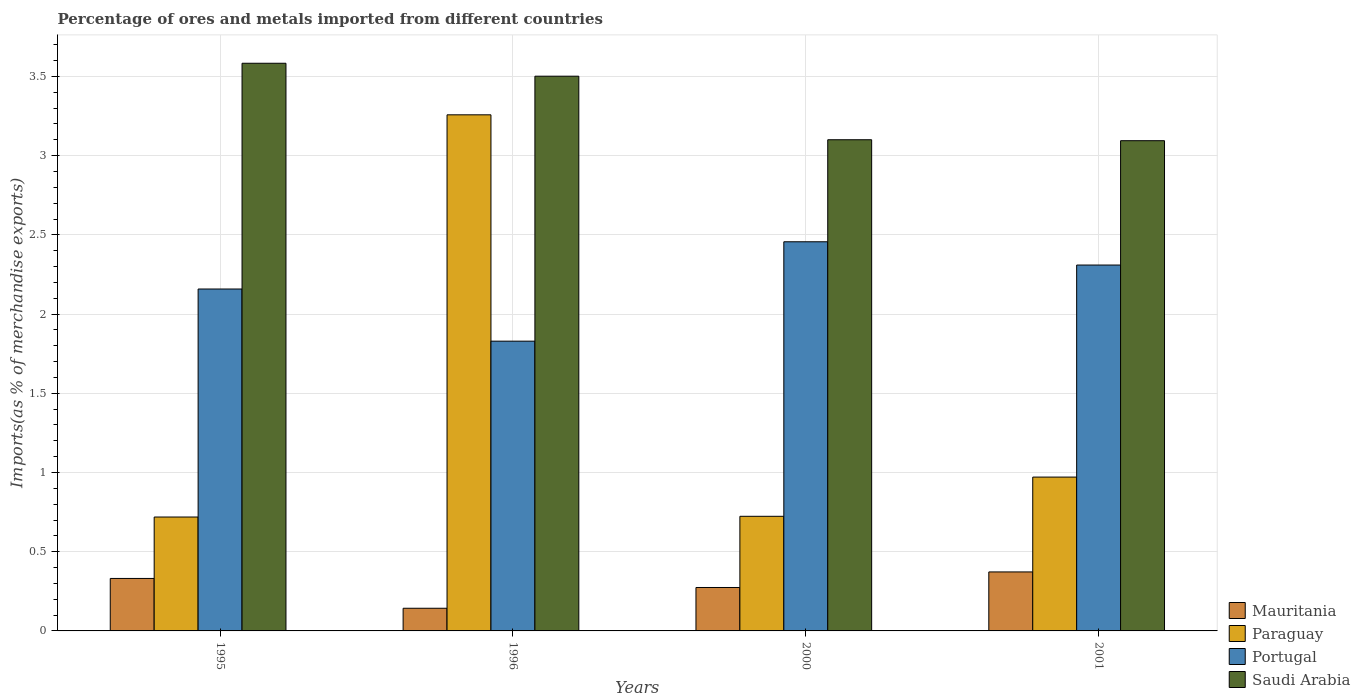How many bars are there on the 1st tick from the left?
Provide a short and direct response. 4. What is the label of the 3rd group of bars from the left?
Offer a terse response. 2000. In how many cases, is the number of bars for a given year not equal to the number of legend labels?
Give a very brief answer. 0. What is the percentage of imports to different countries in Saudi Arabia in 2000?
Offer a very short reply. 3.1. Across all years, what is the maximum percentage of imports to different countries in Mauritania?
Give a very brief answer. 0.37. Across all years, what is the minimum percentage of imports to different countries in Portugal?
Make the answer very short. 1.83. In which year was the percentage of imports to different countries in Saudi Arabia maximum?
Your answer should be very brief. 1995. What is the total percentage of imports to different countries in Saudi Arabia in the graph?
Provide a succinct answer. 13.28. What is the difference between the percentage of imports to different countries in Saudi Arabia in 1996 and that in 2001?
Your answer should be compact. 0.41. What is the difference between the percentage of imports to different countries in Portugal in 1996 and the percentage of imports to different countries in Saudi Arabia in 1995?
Ensure brevity in your answer.  -1.75. What is the average percentage of imports to different countries in Portugal per year?
Offer a very short reply. 2.19. In the year 2001, what is the difference between the percentage of imports to different countries in Mauritania and percentage of imports to different countries in Paraguay?
Make the answer very short. -0.6. What is the ratio of the percentage of imports to different countries in Portugal in 1995 to that in 1996?
Provide a short and direct response. 1.18. Is the difference between the percentage of imports to different countries in Mauritania in 1996 and 2001 greater than the difference between the percentage of imports to different countries in Paraguay in 1996 and 2001?
Offer a terse response. No. What is the difference between the highest and the second highest percentage of imports to different countries in Saudi Arabia?
Offer a very short reply. 0.08. What is the difference between the highest and the lowest percentage of imports to different countries in Paraguay?
Provide a succinct answer. 2.54. In how many years, is the percentage of imports to different countries in Saudi Arabia greater than the average percentage of imports to different countries in Saudi Arabia taken over all years?
Provide a succinct answer. 2. What does the 2nd bar from the left in 2000 represents?
Your response must be concise. Paraguay. What does the 4th bar from the right in 1996 represents?
Ensure brevity in your answer.  Mauritania. Is it the case that in every year, the sum of the percentage of imports to different countries in Portugal and percentage of imports to different countries in Paraguay is greater than the percentage of imports to different countries in Saudi Arabia?
Your response must be concise. No. Are all the bars in the graph horizontal?
Give a very brief answer. No. How many years are there in the graph?
Keep it short and to the point. 4. Does the graph contain any zero values?
Provide a short and direct response. No. Does the graph contain grids?
Ensure brevity in your answer.  Yes. How are the legend labels stacked?
Your answer should be compact. Vertical. What is the title of the graph?
Provide a succinct answer. Percentage of ores and metals imported from different countries. Does "Chad" appear as one of the legend labels in the graph?
Offer a terse response. No. What is the label or title of the Y-axis?
Your answer should be compact. Imports(as % of merchandise exports). What is the Imports(as % of merchandise exports) in Mauritania in 1995?
Provide a short and direct response. 0.33. What is the Imports(as % of merchandise exports) of Paraguay in 1995?
Your response must be concise. 0.72. What is the Imports(as % of merchandise exports) of Portugal in 1995?
Provide a short and direct response. 2.16. What is the Imports(as % of merchandise exports) of Saudi Arabia in 1995?
Offer a very short reply. 3.58. What is the Imports(as % of merchandise exports) in Mauritania in 1996?
Provide a succinct answer. 0.14. What is the Imports(as % of merchandise exports) in Paraguay in 1996?
Make the answer very short. 3.26. What is the Imports(as % of merchandise exports) of Portugal in 1996?
Make the answer very short. 1.83. What is the Imports(as % of merchandise exports) in Saudi Arabia in 1996?
Provide a short and direct response. 3.5. What is the Imports(as % of merchandise exports) of Mauritania in 2000?
Your answer should be very brief. 0.27. What is the Imports(as % of merchandise exports) of Paraguay in 2000?
Keep it short and to the point. 0.72. What is the Imports(as % of merchandise exports) in Portugal in 2000?
Ensure brevity in your answer.  2.46. What is the Imports(as % of merchandise exports) of Saudi Arabia in 2000?
Ensure brevity in your answer.  3.1. What is the Imports(as % of merchandise exports) of Mauritania in 2001?
Offer a very short reply. 0.37. What is the Imports(as % of merchandise exports) in Paraguay in 2001?
Offer a very short reply. 0.97. What is the Imports(as % of merchandise exports) in Portugal in 2001?
Keep it short and to the point. 2.31. What is the Imports(as % of merchandise exports) of Saudi Arabia in 2001?
Your answer should be compact. 3.09. Across all years, what is the maximum Imports(as % of merchandise exports) of Mauritania?
Give a very brief answer. 0.37. Across all years, what is the maximum Imports(as % of merchandise exports) in Paraguay?
Your answer should be very brief. 3.26. Across all years, what is the maximum Imports(as % of merchandise exports) in Portugal?
Provide a succinct answer. 2.46. Across all years, what is the maximum Imports(as % of merchandise exports) of Saudi Arabia?
Ensure brevity in your answer.  3.58. Across all years, what is the minimum Imports(as % of merchandise exports) in Mauritania?
Your answer should be compact. 0.14. Across all years, what is the minimum Imports(as % of merchandise exports) of Paraguay?
Provide a succinct answer. 0.72. Across all years, what is the minimum Imports(as % of merchandise exports) in Portugal?
Give a very brief answer. 1.83. Across all years, what is the minimum Imports(as % of merchandise exports) in Saudi Arabia?
Make the answer very short. 3.09. What is the total Imports(as % of merchandise exports) of Mauritania in the graph?
Your response must be concise. 1.12. What is the total Imports(as % of merchandise exports) in Paraguay in the graph?
Ensure brevity in your answer.  5.67. What is the total Imports(as % of merchandise exports) of Portugal in the graph?
Your answer should be very brief. 8.75. What is the total Imports(as % of merchandise exports) in Saudi Arabia in the graph?
Provide a short and direct response. 13.28. What is the difference between the Imports(as % of merchandise exports) in Mauritania in 1995 and that in 1996?
Your answer should be very brief. 0.19. What is the difference between the Imports(as % of merchandise exports) in Paraguay in 1995 and that in 1996?
Your answer should be very brief. -2.54. What is the difference between the Imports(as % of merchandise exports) of Portugal in 1995 and that in 1996?
Your answer should be compact. 0.33. What is the difference between the Imports(as % of merchandise exports) of Saudi Arabia in 1995 and that in 1996?
Ensure brevity in your answer.  0.08. What is the difference between the Imports(as % of merchandise exports) in Mauritania in 1995 and that in 2000?
Ensure brevity in your answer.  0.06. What is the difference between the Imports(as % of merchandise exports) of Paraguay in 1995 and that in 2000?
Give a very brief answer. -0. What is the difference between the Imports(as % of merchandise exports) in Portugal in 1995 and that in 2000?
Your answer should be compact. -0.3. What is the difference between the Imports(as % of merchandise exports) of Saudi Arabia in 1995 and that in 2000?
Give a very brief answer. 0.48. What is the difference between the Imports(as % of merchandise exports) of Mauritania in 1995 and that in 2001?
Ensure brevity in your answer.  -0.04. What is the difference between the Imports(as % of merchandise exports) of Paraguay in 1995 and that in 2001?
Keep it short and to the point. -0.25. What is the difference between the Imports(as % of merchandise exports) of Portugal in 1995 and that in 2001?
Ensure brevity in your answer.  -0.15. What is the difference between the Imports(as % of merchandise exports) of Saudi Arabia in 1995 and that in 2001?
Ensure brevity in your answer.  0.49. What is the difference between the Imports(as % of merchandise exports) in Mauritania in 1996 and that in 2000?
Provide a succinct answer. -0.13. What is the difference between the Imports(as % of merchandise exports) in Paraguay in 1996 and that in 2000?
Give a very brief answer. 2.53. What is the difference between the Imports(as % of merchandise exports) in Portugal in 1996 and that in 2000?
Your answer should be very brief. -0.63. What is the difference between the Imports(as % of merchandise exports) of Saudi Arabia in 1996 and that in 2000?
Give a very brief answer. 0.4. What is the difference between the Imports(as % of merchandise exports) in Mauritania in 1996 and that in 2001?
Provide a short and direct response. -0.23. What is the difference between the Imports(as % of merchandise exports) in Paraguay in 1996 and that in 2001?
Your answer should be very brief. 2.29. What is the difference between the Imports(as % of merchandise exports) in Portugal in 1996 and that in 2001?
Offer a terse response. -0.48. What is the difference between the Imports(as % of merchandise exports) in Saudi Arabia in 1996 and that in 2001?
Ensure brevity in your answer.  0.41. What is the difference between the Imports(as % of merchandise exports) of Mauritania in 2000 and that in 2001?
Ensure brevity in your answer.  -0.1. What is the difference between the Imports(as % of merchandise exports) of Paraguay in 2000 and that in 2001?
Offer a very short reply. -0.25. What is the difference between the Imports(as % of merchandise exports) of Portugal in 2000 and that in 2001?
Give a very brief answer. 0.15. What is the difference between the Imports(as % of merchandise exports) of Saudi Arabia in 2000 and that in 2001?
Give a very brief answer. 0.01. What is the difference between the Imports(as % of merchandise exports) of Mauritania in 1995 and the Imports(as % of merchandise exports) of Paraguay in 1996?
Offer a terse response. -2.93. What is the difference between the Imports(as % of merchandise exports) in Mauritania in 1995 and the Imports(as % of merchandise exports) in Portugal in 1996?
Provide a short and direct response. -1.5. What is the difference between the Imports(as % of merchandise exports) of Mauritania in 1995 and the Imports(as % of merchandise exports) of Saudi Arabia in 1996?
Keep it short and to the point. -3.17. What is the difference between the Imports(as % of merchandise exports) of Paraguay in 1995 and the Imports(as % of merchandise exports) of Portugal in 1996?
Provide a short and direct response. -1.11. What is the difference between the Imports(as % of merchandise exports) of Paraguay in 1995 and the Imports(as % of merchandise exports) of Saudi Arabia in 1996?
Keep it short and to the point. -2.78. What is the difference between the Imports(as % of merchandise exports) in Portugal in 1995 and the Imports(as % of merchandise exports) in Saudi Arabia in 1996?
Offer a terse response. -1.34. What is the difference between the Imports(as % of merchandise exports) in Mauritania in 1995 and the Imports(as % of merchandise exports) in Paraguay in 2000?
Offer a terse response. -0.39. What is the difference between the Imports(as % of merchandise exports) in Mauritania in 1995 and the Imports(as % of merchandise exports) in Portugal in 2000?
Provide a short and direct response. -2.13. What is the difference between the Imports(as % of merchandise exports) in Mauritania in 1995 and the Imports(as % of merchandise exports) in Saudi Arabia in 2000?
Provide a short and direct response. -2.77. What is the difference between the Imports(as % of merchandise exports) in Paraguay in 1995 and the Imports(as % of merchandise exports) in Portugal in 2000?
Make the answer very short. -1.74. What is the difference between the Imports(as % of merchandise exports) in Paraguay in 1995 and the Imports(as % of merchandise exports) in Saudi Arabia in 2000?
Give a very brief answer. -2.38. What is the difference between the Imports(as % of merchandise exports) in Portugal in 1995 and the Imports(as % of merchandise exports) in Saudi Arabia in 2000?
Make the answer very short. -0.94. What is the difference between the Imports(as % of merchandise exports) of Mauritania in 1995 and the Imports(as % of merchandise exports) of Paraguay in 2001?
Ensure brevity in your answer.  -0.64. What is the difference between the Imports(as % of merchandise exports) of Mauritania in 1995 and the Imports(as % of merchandise exports) of Portugal in 2001?
Provide a succinct answer. -1.98. What is the difference between the Imports(as % of merchandise exports) of Mauritania in 1995 and the Imports(as % of merchandise exports) of Saudi Arabia in 2001?
Ensure brevity in your answer.  -2.76. What is the difference between the Imports(as % of merchandise exports) of Paraguay in 1995 and the Imports(as % of merchandise exports) of Portugal in 2001?
Keep it short and to the point. -1.59. What is the difference between the Imports(as % of merchandise exports) in Paraguay in 1995 and the Imports(as % of merchandise exports) in Saudi Arabia in 2001?
Offer a very short reply. -2.38. What is the difference between the Imports(as % of merchandise exports) of Portugal in 1995 and the Imports(as % of merchandise exports) of Saudi Arabia in 2001?
Provide a succinct answer. -0.94. What is the difference between the Imports(as % of merchandise exports) of Mauritania in 1996 and the Imports(as % of merchandise exports) of Paraguay in 2000?
Provide a succinct answer. -0.58. What is the difference between the Imports(as % of merchandise exports) of Mauritania in 1996 and the Imports(as % of merchandise exports) of Portugal in 2000?
Give a very brief answer. -2.31. What is the difference between the Imports(as % of merchandise exports) in Mauritania in 1996 and the Imports(as % of merchandise exports) in Saudi Arabia in 2000?
Offer a very short reply. -2.96. What is the difference between the Imports(as % of merchandise exports) of Paraguay in 1996 and the Imports(as % of merchandise exports) of Portugal in 2000?
Give a very brief answer. 0.8. What is the difference between the Imports(as % of merchandise exports) in Paraguay in 1996 and the Imports(as % of merchandise exports) in Saudi Arabia in 2000?
Keep it short and to the point. 0.16. What is the difference between the Imports(as % of merchandise exports) of Portugal in 1996 and the Imports(as % of merchandise exports) of Saudi Arabia in 2000?
Make the answer very short. -1.27. What is the difference between the Imports(as % of merchandise exports) of Mauritania in 1996 and the Imports(as % of merchandise exports) of Paraguay in 2001?
Give a very brief answer. -0.83. What is the difference between the Imports(as % of merchandise exports) in Mauritania in 1996 and the Imports(as % of merchandise exports) in Portugal in 2001?
Offer a very short reply. -2.17. What is the difference between the Imports(as % of merchandise exports) of Mauritania in 1996 and the Imports(as % of merchandise exports) of Saudi Arabia in 2001?
Provide a succinct answer. -2.95. What is the difference between the Imports(as % of merchandise exports) of Paraguay in 1996 and the Imports(as % of merchandise exports) of Portugal in 2001?
Your answer should be very brief. 0.95. What is the difference between the Imports(as % of merchandise exports) in Paraguay in 1996 and the Imports(as % of merchandise exports) in Saudi Arabia in 2001?
Ensure brevity in your answer.  0.16. What is the difference between the Imports(as % of merchandise exports) of Portugal in 1996 and the Imports(as % of merchandise exports) of Saudi Arabia in 2001?
Make the answer very short. -1.27. What is the difference between the Imports(as % of merchandise exports) of Mauritania in 2000 and the Imports(as % of merchandise exports) of Paraguay in 2001?
Offer a very short reply. -0.7. What is the difference between the Imports(as % of merchandise exports) of Mauritania in 2000 and the Imports(as % of merchandise exports) of Portugal in 2001?
Give a very brief answer. -2.04. What is the difference between the Imports(as % of merchandise exports) of Mauritania in 2000 and the Imports(as % of merchandise exports) of Saudi Arabia in 2001?
Keep it short and to the point. -2.82. What is the difference between the Imports(as % of merchandise exports) in Paraguay in 2000 and the Imports(as % of merchandise exports) in Portugal in 2001?
Provide a succinct answer. -1.59. What is the difference between the Imports(as % of merchandise exports) of Paraguay in 2000 and the Imports(as % of merchandise exports) of Saudi Arabia in 2001?
Keep it short and to the point. -2.37. What is the difference between the Imports(as % of merchandise exports) in Portugal in 2000 and the Imports(as % of merchandise exports) in Saudi Arabia in 2001?
Your answer should be compact. -0.64. What is the average Imports(as % of merchandise exports) of Mauritania per year?
Offer a very short reply. 0.28. What is the average Imports(as % of merchandise exports) of Paraguay per year?
Offer a terse response. 1.42. What is the average Imports(as % of merchandise exports) in Portugal per year?
Provide a short and direct response. 2.19. What is the average Imports(as % of merchandise exports) of Saudi Arabia per year?
Offer a terse response. 3.32. In the year 1995, what is the difference between the Imports(as % of merchandise exports) of Mauritania and Imports(as % of merchandise exports) of Paraguay?
Make the answer very short. -0.39. In the year 1995, what is the difference between the Imports(as % of merchandise exports) in Mauritania and Imports(as % of merchandise exports) in Portugal?
Your answer should be compact. -1.83. In the year 1995, what is the difference between the Imports(as % of merchandise exports) of Mauritania and Imports(as % of merchandise exports) of Saudi Arabia?
Provide a succinct answer. -3.25. In the year 1995, what is the difference between the Imports(as % of merchandise exports) of Paraguay and Imports(as % of merchandise exports) of Portugal?
Your answer should be very brief. -1.44. In the year 1995, what is the difference between the Imports(as % of merchandise exports) of Paraguay and Imports(as % of merchandise exports) of Saudi Arabia?
Your answer should be very brief. -2.86. In the year 1995, what is the difference between the Imports(as % of merchandise exports) in Portugal and Imports(as % of merchandise exports) in Saudi Arabia?
Keep it short and to the point. -1.43. In the year 1996, what is the difference between the Imports(as % of merchandise exports) in Mauritania and Imports(as % of merchandise exports) in Paraguay?
Provide a succinct answer. -3.11. In the year 1996, what is the difference between the Imports(as % of merchandise exports) in Mauritania and Imports(as % of merchandise exports) in Portugal?
Provide a succinct answer. -1.69. In the year 1996, what is the difference between the Imports(as % of merchandise exports) of Mauritania and Imports(as % of merchandise exports) of Saudi Arabia?
Your response must be concise. -3.36. In the year 1996, what is the difference between the Imports(as % of merchandise exports) of Paraguay and Imports(as % of merchandise exports) of Portugal?
Offer a terse response. 1.43. In the year 1996, what is the difference between the Imports(as % of merchandise exports) of Paraguay and Imports(as % of merchandise exports) of Saudi Arabia?
Your response must be concise. -0.24. In the year 1996, what is the difference between the Imports(as % of merchandise exports) of Portugal and Imports(as % of merchandise exports) of Saudi Arabia?
Ensure brevity in your answer.  -1.67. In the year 2000, what is the difference between the Imports(as % of merchandise exports) in Mauritania and Imports(as % of merchandise exports) in Paraguay?
Provide a succinct answer. -0.45. In the year 2000, what is the difference between the Imports(as % of merchandise exports) in Mauritania and Imports(as % of merchandise exports) in Portugal?
Offer a terse response. -2.18. In the year 2000, what is the difference between the Imports(as % of merchandise exports) in Mauritania and Imports(as % of merchandise exports) in Saudi Arabia?
Keep it short and to the point. -2.83. In the year 2000, what is the difference between the Imports(as % of merchandise exports) in Paraguay and Imports(as % of merchandise exports) in Portugal?
Give a very brief answer. -1.73. In the year 2000, what is the difference between the Imports(as % of merchandise exports) of Paraguay and Imports(as % of merchandise exports) of Saudi Arabia?
Offer a terse response. -2.38. In the year 2000, what is the difference between the Imports(as % of merchandise exports) in Portugal and Imports(as % of merchandise exports) in Saudi Arabia?
Provide a succinct answer. -0.64. In the year 2001, what is the difference between the Imports(as % of merchandise exports) in Mauritania and Imports(as % of merchandise exports) in Paraguay?
Offer a very short reply. -0.6. In the year 2001, what is the difference between the Imports(as % of merchandise exports) of Mauritania and Imports(as % of merchandise exports) of Portugal?
Provide a succinct answer. -1.94. In the year 2001, what is the difference between the Imports(as % of merchandise exports) in Mauritania and Imports(as % of merchandise exports) in Saudi Arabia?
Keep it short and to the point. -2.72. In the year 2001, what is the difference between the Imports(as % of merchandise exports) in Paraguay and Imports(as % of merchandise exports) in Portugal?
Give a very brief answer. -1.34. In the year 2001, what is the difference between the Imports(as % of merchandise exports) in Paraguay and Imports(as % of merchandise exports) in Saudi Arabia?
Give a very brief answer. -2.12. In the year 2001, what is the difference between the Imports(as % of merchandise exports) of Portugal and Imports(as % of merchandise exports) of Saudi Arabia?
Offer a terse response. -0.78. What is the ratio of the Imports(as % of merchandise exports) in Mauritania in 1995 to that in 1996?
Ensure brevity in your answer.  2.32. What is the ratio of the Imports(as % of merchandise exports) in Paraguay in 1995 to that in 1996?
Make the answer very short. 0.22. What is the ratio of the Imports(as % of merchandise exports) of Portugal in 1995 to that in 1996?
Provide a succinct answer. 1.18. What is the ratio of the Imports(as % of merchandise exports) of Saudi Arabia in 1995 to that in 1996?
Offer a terse response. 1.02. What is the ratio of the Imports(as % of merchandise exports) of Mauritania in 1995 to that in 2000?
Make the answer very short. 1.21. What is the ratio of the Imports(as % of merchandise exports) in Portugal in 1995 to that in 2000?
Provide a short and direct response. 0.88. What is the ratio of the Imports(as % of merchandise exports) in Saudi Arabia in 1995 to that in 2000?
Ensure brevity in your answer.  1.16. What is the ratio of the Imports(as % of merchandise exports) in Mauritania in 1995 to that in 2001?
Give a very brief answer. 0.89. What is the ratio of the Imports(as % of merchandise exports) of Paraguay in 1995 to that in 2001?
Keep it short and to the point. 0.74. What is the ratio of the Imports(as % of merchandise exports) of Portugal in 1995 to that in 2001?
Ensure brevity in your answer.  0.93. What is the ratio of the Imports(as % of merchandise exports) in Saudi Arabia in 1995 to that in 2001?
Your response must be concise. 1.16. What is the ratio of the Imports(as % of merchandise exports) of Mauritania in 1996 to that in 2000?
Your response must be concise. 0.52. What is the ratio of the Imports(as % of merchandise exports) of Paraguay in 1996 to that in 2000?
Offer a terse response. 4.5. What is the ratio of the Imports(as % of merchandise exports) in Portugal in 1996 to that in 2000?
Your answer should be compact. 0.74. What is the ratio of the Imports(as % of merchandise exports) in Saudi Arabia in 1996 to that in 2000?
Offer a terse response. 1.13. What is the ratio of the Imports(as % of merchandise exports) of Mauritania in 1996 to that in 2001?
Make the answer very short. 0.38. What is the ratio of the Imports(as % of merchandise exports) in Paraguay in 1996 to that in 2001?
Your response must be concise. 3.35. What is the ratio of the Imports(as % of merchandise exports) of Portugal in 1996 to that in 2001?
Provide a short and direct response. 0.79. What is the ratio of the Imports(as % of merchandise exports) in Saudi Arabia in 1996 to that in 2001?
Provide a succinct answer. 1.13. What is the ratio of the Imports(as % of merchandise exports) of Mauritania in 2000 to that in 2001?
Offer a terse response. 0.74. What is the ratio of the Imports(as % of merchandise exports) in Paraguay in 2000 to that in 2001?
Offer a terse response. 0.74. What is the ratio of the Imports(as % of merchandise exports) in Portugal in 2000 to that in 2001?
Your answer should be very brief. 1.06. What is the ratio of the Imports(as % of merchandise exports) of Saudi Arabia in 2000 to that in 2001?
Your answer should be compact. 1. What is the difference between the highest and the second highest Imports(as % of merchandise exports) in Mauritania?
Provide a short and direct response. 0.04. What is the difference between the highest and the second highest Imports(as % of merchandise exports) in Paraguay?
Give a very brief answer. 2.29. What is the difference between the highest and the second highest Imports(as % of merchandise exports) in Portugal?
Make the answer very short. 0.15. What is the difference between the highest and the second highest Imports(as % of merchandise exports) of Saudi Arabia?
Your answer should be compact. 0.08. What is the difference between the highest and the lowest Imports(as % of merchandise exports) in Mauritania?
Offer a terse response. 0.23. What is the difference between the highest and the lowest Imports(as % of merchandise exports) of Paraguay?
Your answer should be very brief. 2.54. What is the difference between the highest and the lowest Imports(as % of merchandise exports) of Portugal?
Offer a terse response. 0.63. What is the difference between the highest and the lowest Imports(as % of merchandise exports) of Saudi Arabia?
Provide a short and direct response. 0.49. 